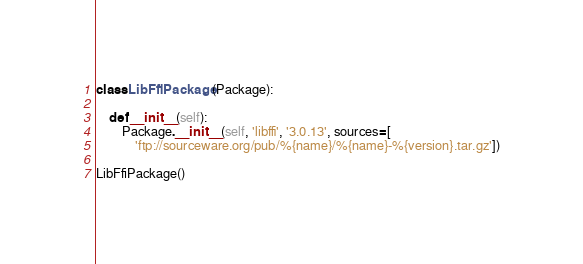Convert code to text. <code><loc_0><loc_0><loc_500><loc_500><_Python_>class LibFfiPackage (Package):

    def __init__(self):
        Package.__init__(self, 'libffi', '3.0.13', sources=[
            'ftp://sourceware.org/pub/%{name}/%{name}-%{version}.tar.gz'])

LibFfiPackage()
</code> 